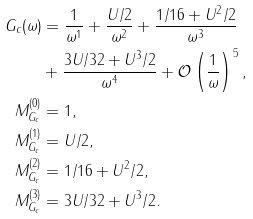<formula> <loc_0><loc_0><loc_500><loc_500>G _ { c } ( \omega ) & = \frac { 1 } { \omega ^ { 1 } } + \frac { U / 2 } { \omega ^ { 2 } } + \frac { 1 / 1 6 + U ^ { 2 } / 2 } { \omega ^ { 3 } } \\ & + \frac { 3 U / 3 2 + U ^ { 3 } / 2 } { \omega ^ { 4 } } + \mathcal { O } \left ( \frac { 1 } { \omega } \right ) ^ { 5 } , \\ M ^ { ( 0 ) } _ { G _ { c } } & = 1 , \\ M ^ { ( 1 ) } _ { G _ { c } } & = U / 2 , \\ M ^ { ( 2 ) } _ { G _ { c } } & = 1 / 1 6 + U ^ { 2 } / 2 , \\ M ^ { ( 3 ) } _ { G _ { c } } & = 3 U / 3 2 + U ^ { 3 } / 2 .</formula> 